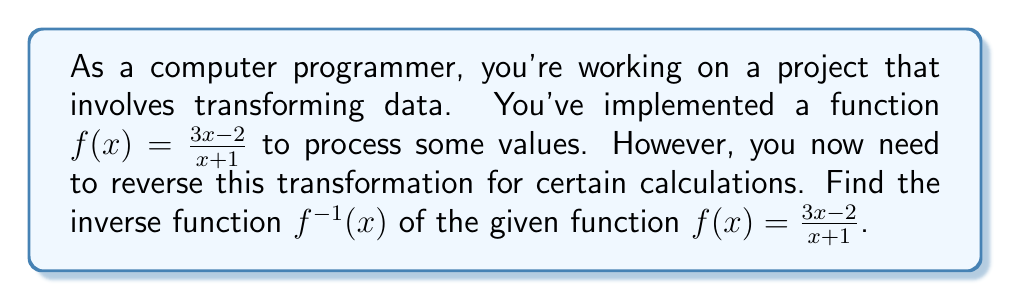Teach me how to tackle this problem. To find the inverse function, we'll follow these steps:

1) Replace $f(x)$ with $y$:
   $$y = \frac{3x - 2}{x + 1}$$

2) Interchange $x$ and $y$:
   $$x = \frac{3y - 2}{y + 1}$$

3) Solve for $y$:
   
   Multiply both sides by $(y + 1)$:
   $$x(y + 1) = 3y - 2$$
   
   Distribute $x$:
   $$xy + x = 3y - 2$$
   
   Subtract $3y$ from both sides:
   $$xy - 3y + x = -2$$
   
   Factor out $y$:
   $$y(x - 3) + x = -2$$
   
   Subtract $x$ from both sides:
   $$y(x - 3) = -x - 2$$
   
   Divide both sides by $(x - 3)$:
   $$y = \frac{-x - 2}{x - 3}$$

4) Replace $y$ with $f^{-1}(x)$:
   $$f^{-1}(x) = \frac{-x - 2}{x - 3}$$

Thus, we have found the inverse function.
Answer: $f^{-1}(x) = \frac{-x - 2}{x - 3}$ 